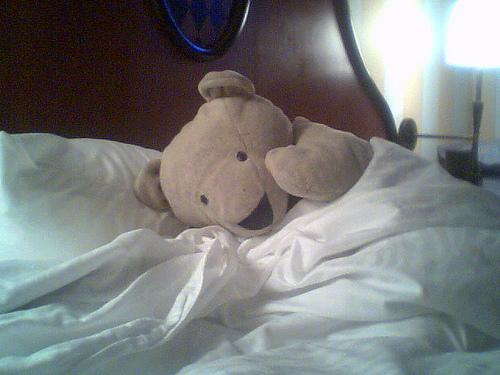Is the bear sleeping?
Keep it brief. No. Does this bed belong to the bear?
Short answer required. No. What color are the sheets?
Keep it brief. White. 